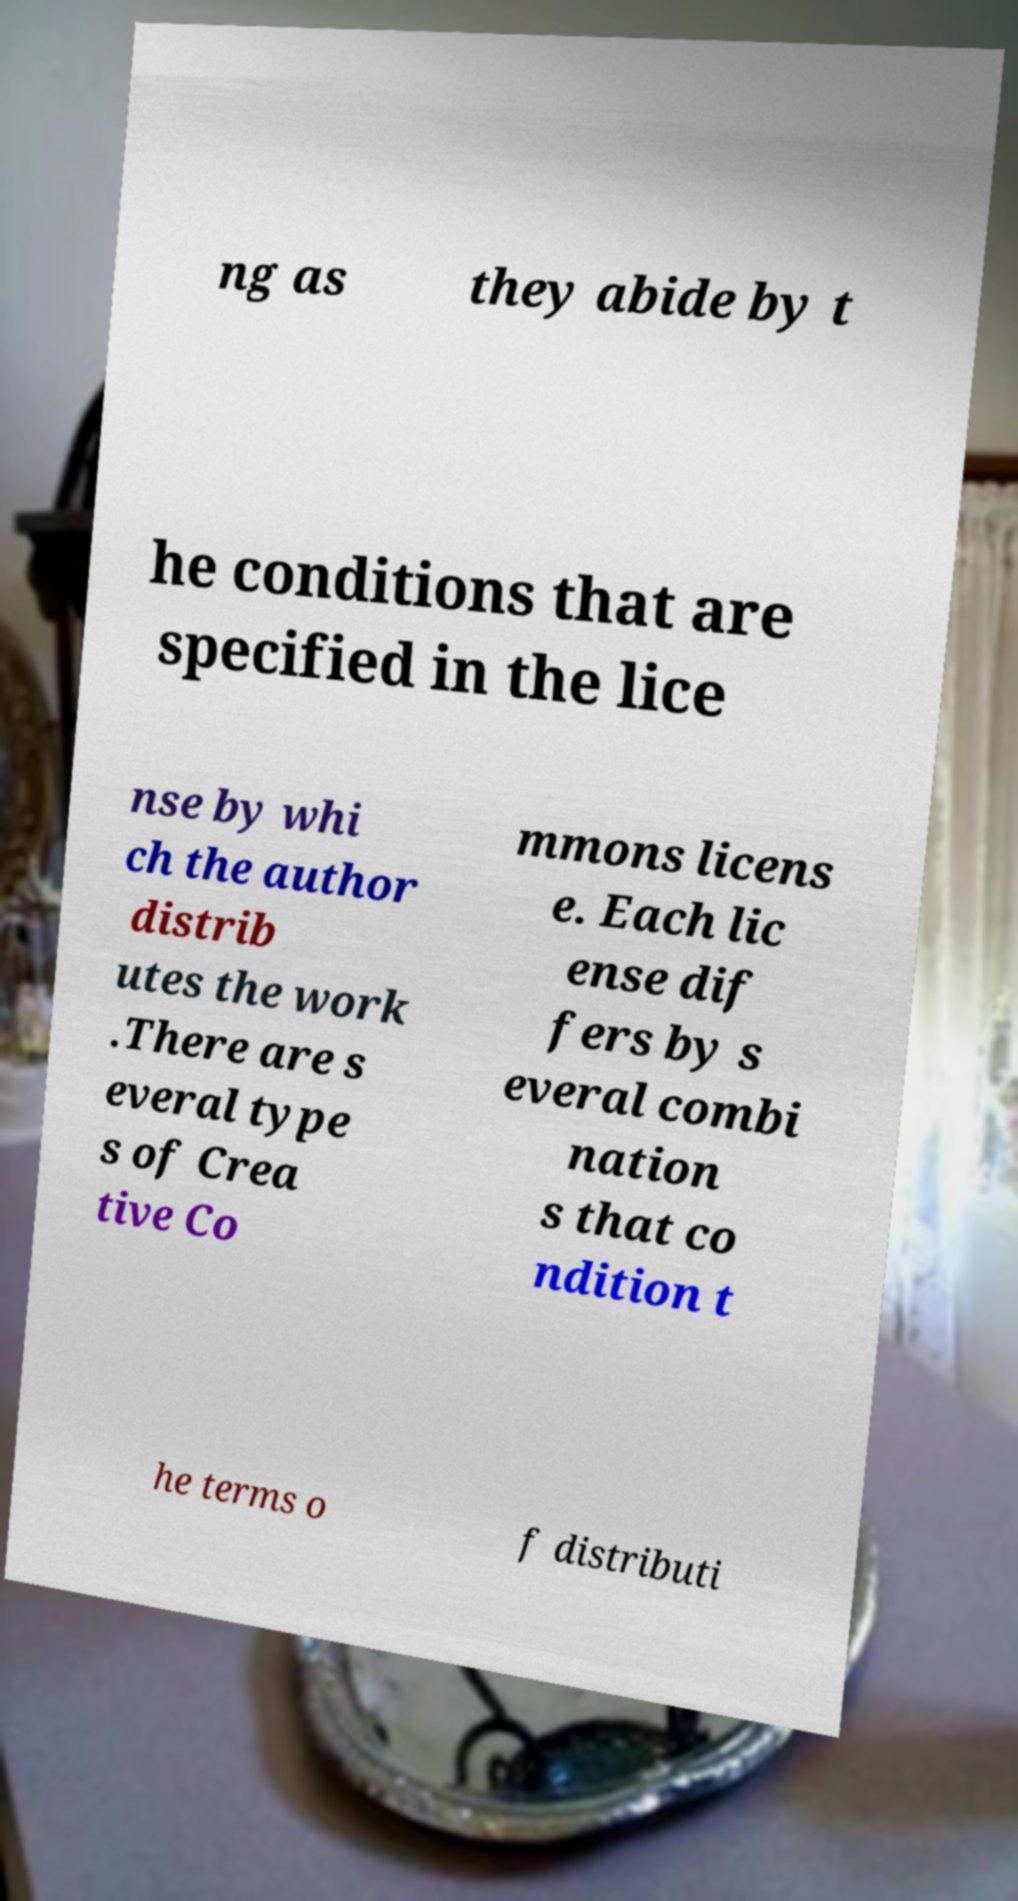Could you assist in decoding the text presented in this image and type it out clearly? ng as they abide by t he conditions that are specified in the lice nse by whi ch the author distrib utes the work .There are s everal type s of Crea tive Co mmons licens e. Each lic ense dif fers by s everal combi nation s that co ndition t he terms o f distributi 